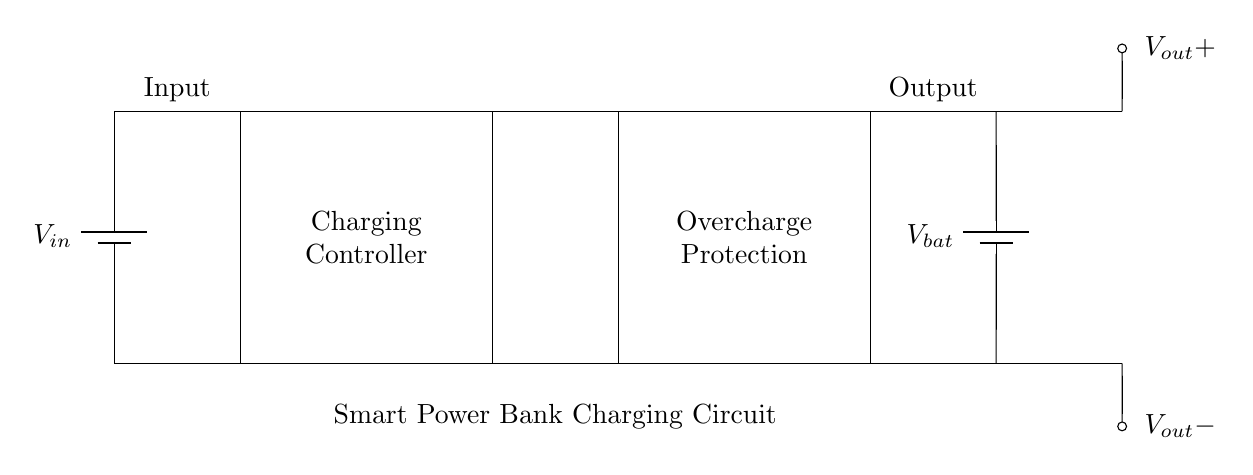what is the input source of this circuit? The circuit shows a battery labeled as V_in, indicating that the input source is a battery.
Answer: battery what is the purpose of the charging controller? The charging controller is responsible for managing the charging process of the battery to avoid overcharging.
Answer: manage charging how many components are used in the circuit? There are four main components: an input battery, a charging controller, an overcharge protection block, and an output battery.
Answer: four what type of protection does this circuit provide? The circuit provides overcharge protection, which prevents the battery from charging beyond its capacity.
Answer: overcharge protection what voltage does the output battery provide? The output battery is labeled as V_bat, indicating that it provides the stored voltage output.
Answer: V_bat what is the relationship between the charging controller and the battery? The charging controller regulates the charging process, allowing current to flow from the input to the battery while preventing overcharging.
Answer: regulates charging how does the overcharge protection affect the circuit's functionality? The overcharge protection ensures that once the battery reaches full charge, the current flow is stopped, thereby preventing damage from overcharging.
Answer: prevents damage 